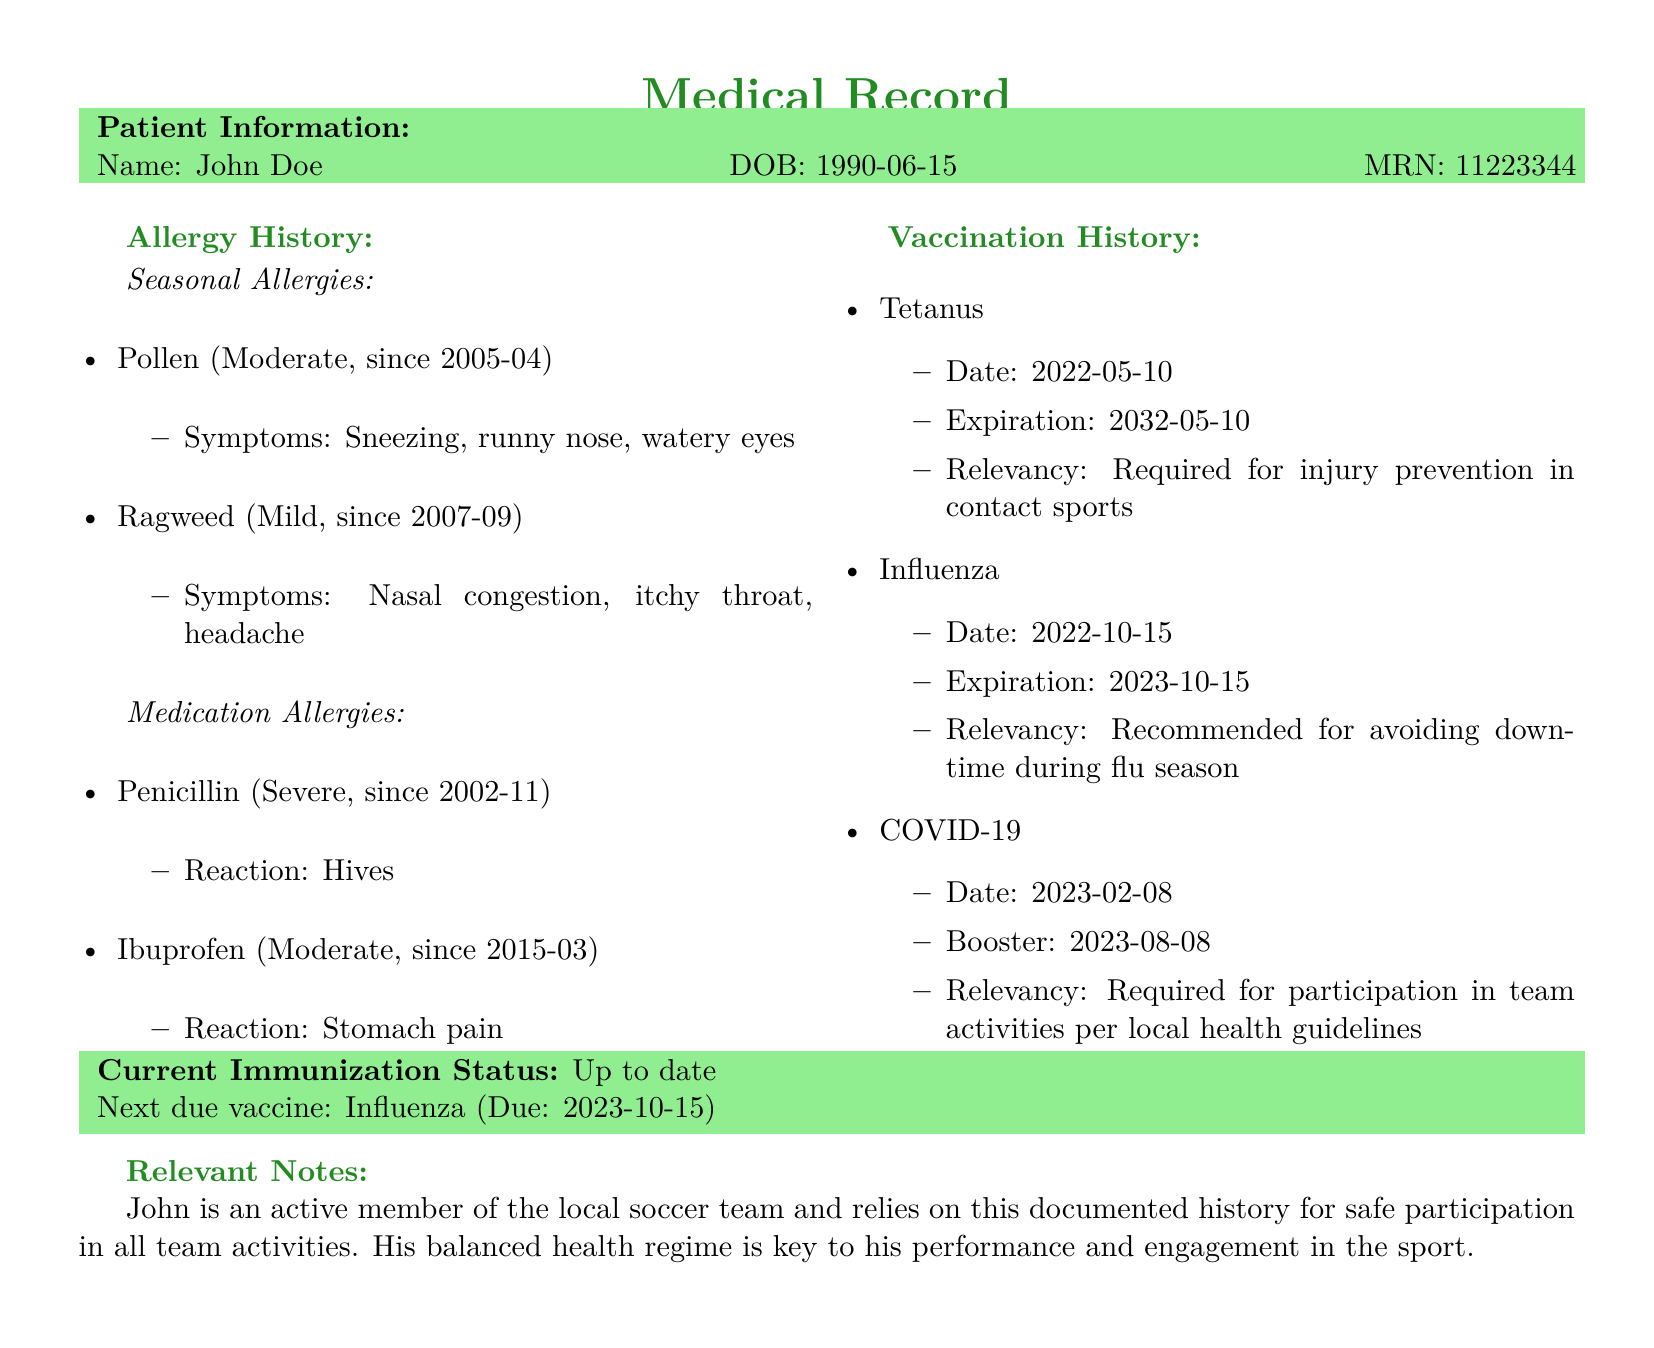What is the patient's name? The name of the patient is mentioned at the beginning of the document, which is John Doe.
Answer: John Doe What is the patient's date of birth? The patient's date of birth is provided along with their information, which is 1990-06-15.
Answer: 1990-06-15 What medication is John allergic to? The document lists the medication allergies, including Penicillin, which John is severely allergic to.
Answer: Penicillin What are John's seasonal allergies? The document includes seasonal allergies, specifically pollen and ragweed as John's allergies.
Answer: Pollen, Ragweed When was John’s last Tetanus vaccination? The vaccination history section provides the date of John’s last Tetanus vaccination, which is 2022-05-10.
Answer: 2022-05-10 What is the next due vaccine for John? The document specifies the next due vaccine for John, which is the Influenza vaccine.
Answer: Influenza What is John's current immunization status? The document clearly states John's current immunization status as "Up to date."
Answer: Up to date How long has John had a pollen allergy? The start date of John’s pollen allergy is noted as 2005-04, indicating he has had it for a long time.
Answer: Since 2005-04 What is the relevance of the COVID-19 vaccine? The document summarizes the relevance of the COVID-19 vaccine concerning participation in team activities.
Answer: Required for participation in team activities What symptom is associated with John's allergy to Ragweed? The document lists symptoms associated with Ragweed, which include nasal congestion, itchy throat, and headache.
Answer: Nasal congestion, itchy throat, headache 